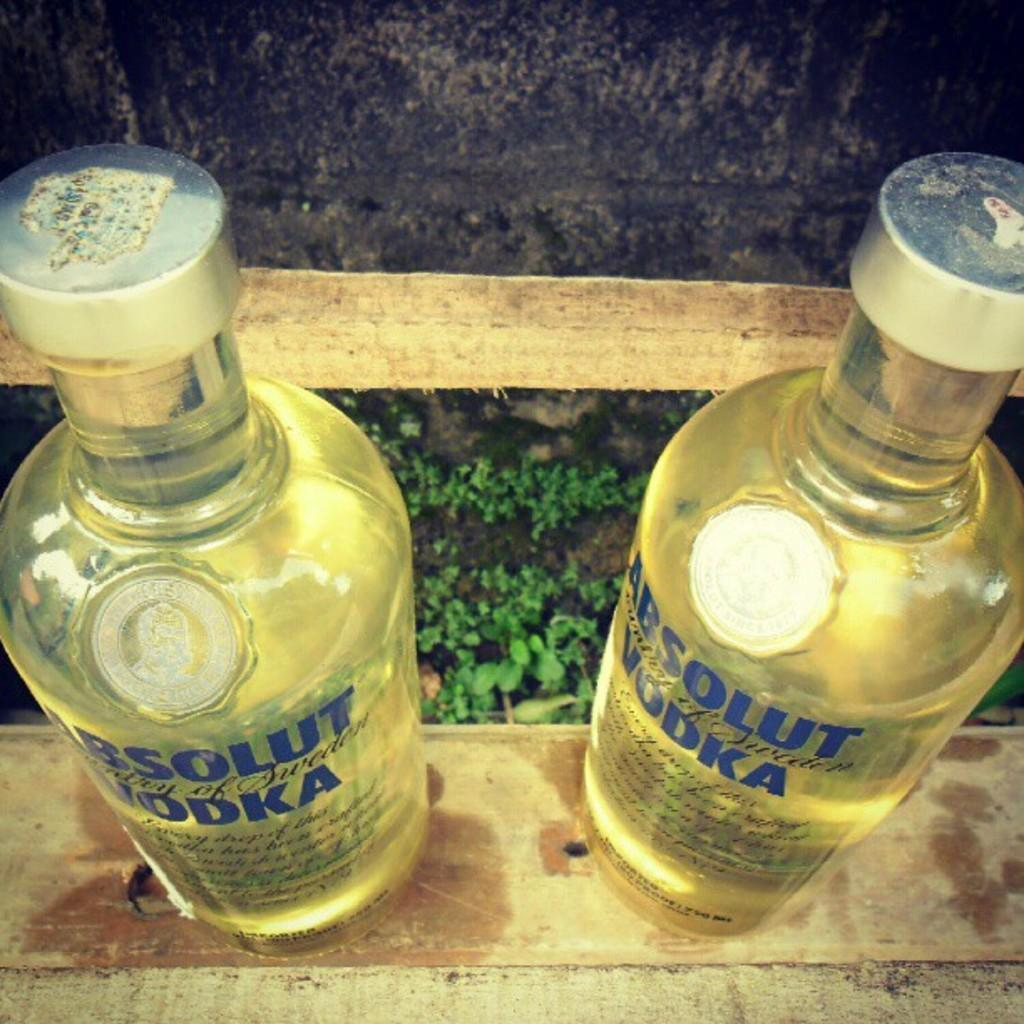<image>
Give a short and clear explanation of the subsequent image. Two bottles of Absolut vodka are sitting on a wooden railing 